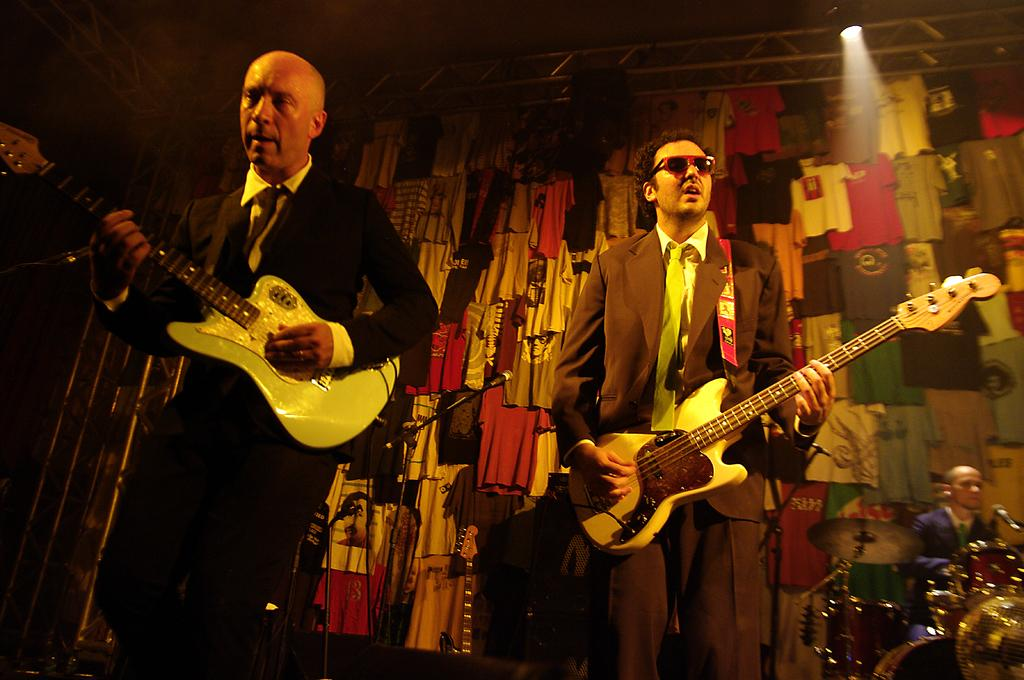How many people are in the image? There are 2 people standing in the image. What are the 2 people doing? The 2 people are playing guitar. Are there any other musicians in the image? Yes, there is a person playing drums in the image. What can be seen in the background of the image? T-shirts are hanging in the background. What type of hose is being used by the guitarist in the image? There is no hose present in the image; the people are playing musical instruments. 